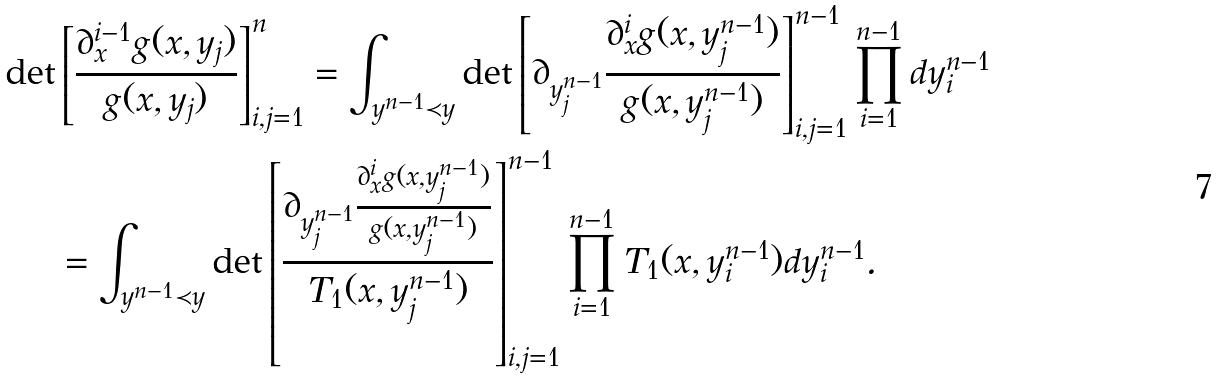<formula> <loc_0><loc_0><loc_500><loc_500>\det & \left [ \frac { \partial _ { x } ^ { i - 1 } g ( x , y _ { j } ) } { g ( x , y _ { j } ) } \right ] _ { i , j = 1 } ^ { n } = \int _ { y ^ { n - 1 } \prec y } \det \left [ \partial _ { y ^ { n - 1 } _ { j } } \frac { \partial _ { x } ^ { i } g ( x , y ^ { n - 1 } _ { j } ) } { g ( x , y ^ { n - 1 } _ { j } ) } \right ] _ { i , j = 1 } ^ { n - 1 } \prod _ { i = 1 } ^ { n - 1 } d y ^ { n - 1 } _ { i } \\ & = \int _ { y ^ { n - 1 } \prec y } \det \left [ \frac { \partial _ { y ^ { n - 1 } _ { j } } \frac { \partial _ { x } ^ { i } g ( x , y ^ { n - 1 } _ { j } ) } { g ( x , y ^ { n - 1 } _ { j } ) } } { T _ { 1 } ( x , y _ { j } ^ { n - 1 } ) } \right ] _ { i , j = 1 } ^ { n - 1 } \prod _ { i = 1 } ^ { n - 1 } T _ { 1 } ( x , y ^ { n - 1 } _ { i } ) d y ^ { n - 1 } _ { i } .</formula> 